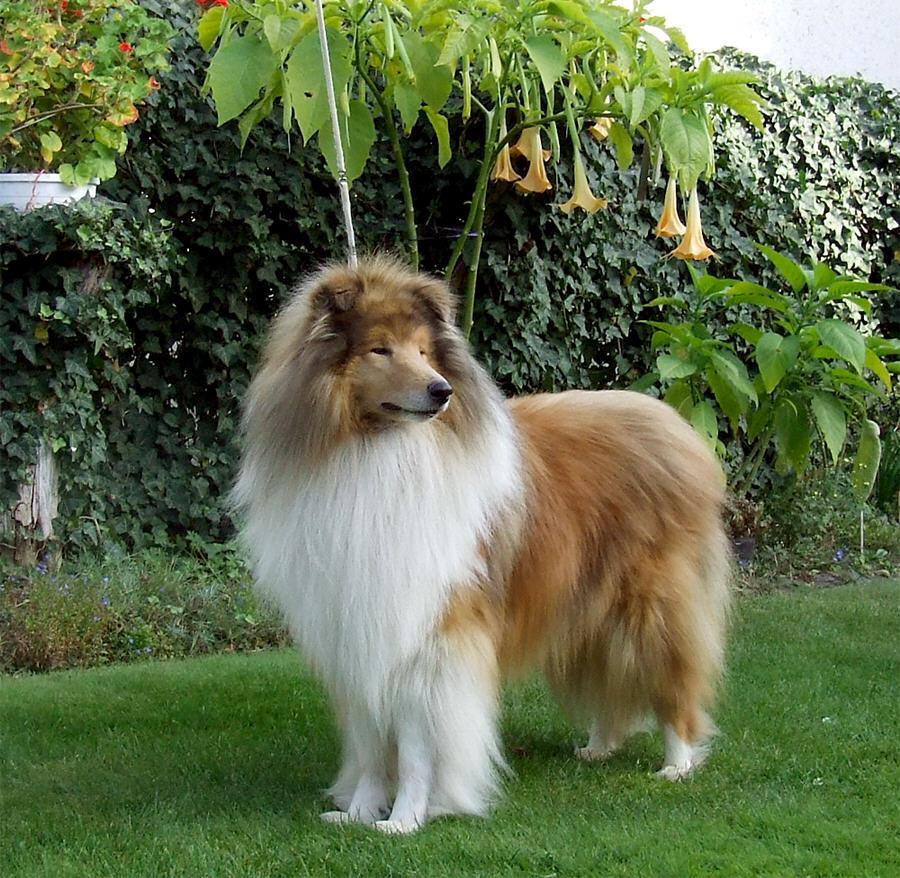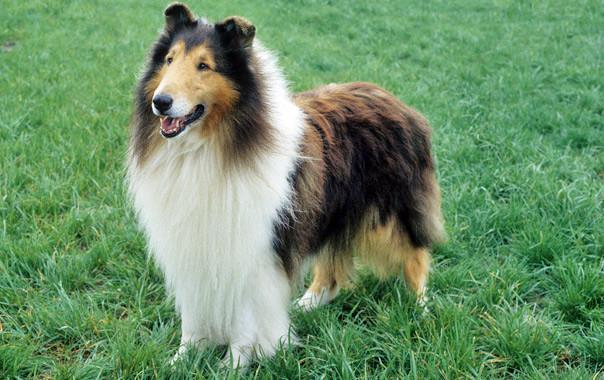The first image is the image on the left, the second image is the image on the right. For the images displayed, is the sentence "both collies are standing and facing left" factually correct? Answer yes or no. Yes. 